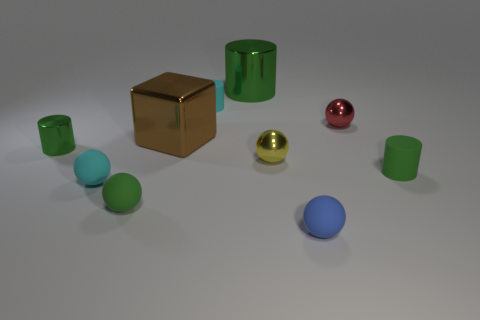What is the large cylinder made of?
Offer a terse response. Metal. Are there more red metallic spheres behind the big cylinder than cyan matte balls?
Your response must be concise. No. How many cyan cylinders are on the left side of the tiny green object that is in front of the tiny rubber cylinder on the right side of the yellow thing?
Your response must be concise. 0. The object that is both to the right of the cyan cylinder and behind the small red metallic sphere is made of what material?
Give a very brief answer. Metal. What color is the big cylinder?
Your answer should be very brief. Green. Is the number of tiny cyan matte cylinders on the right side of the tiny red thing greater than the number of large cylinders that are to the right of the tiny green rubber cylinder?
Offer a very short reply. No. What color is the small metal sphere that is in front of the tiny red metallic ball?
Ensure brevity in your answer.  Yellow. Does the green rubber thing right of the large green metallic thing have the same size as the shiny object right of the small yellow shiny ball?
Keep it short and to the point. Yes. How many objects are either big green shiny things or gray shiny objects?
Give a very brief answer. 1. What is the big thing that is on the left side of the small cyan rubber thing behind the large brown block made of?
Your response must be concise. Metal. 